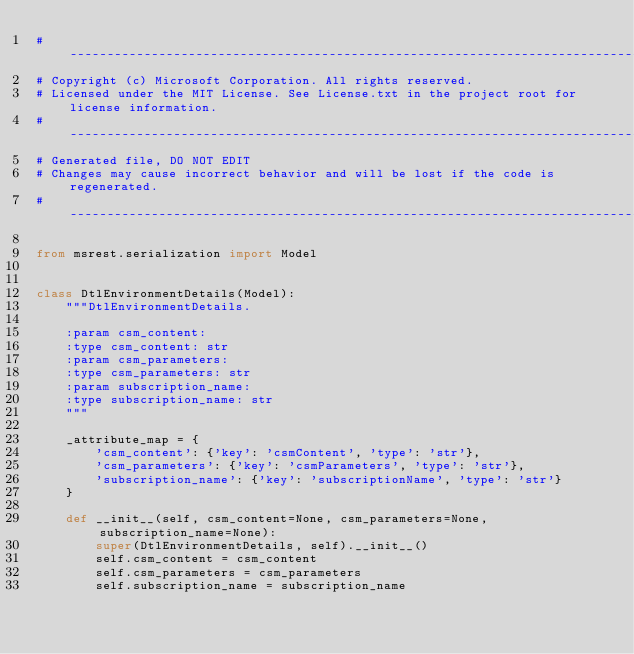<code> <loc_0><loc_0><loc_500><loc_500><_Python_># --------------------------------------------------------------------------------------------
# Copyright (c) Microsoft Corporation. All rights reserved.
# Licensed under the MIT License. See License.txt in the project root for license information.
# --------------------------------------------------------------------------------------------
# Generated file, DO NOT EDIT
# Changes may cause incorrect behavior and will be lost if the code is regenerated.
# --------------------------------------------------------------------------------------------

from msrest.serialization import Model


class DtlEnvironmentDetails(Model):
    """DtlEnvironmentDetails.

    :param csm_content:
    :type csm_content: str
    :param csm_parameters:
    :type csm_parameters: str
    :param subscription_name:
    :type subscription_name: str
    """

    _attribute_map = {
        'csm_content': {'key': 'csmContent', 'type': 'str'},
        'csm_parameters': {'key': 'csmParameters', 'type': 'str'},
        'subscription_name': {'key': 'subscriptionName', 'type': 'str'}
    }

    def __init__(self, csm_content=None, csm_parameters=None, subscription_name=None):
        super(DtlEnvironmentDetails, self).__init__()
        self.csm_content = csm_content
        self.csm_parameters = csm_parameters
        self.subscription_name = subscription_name
</code> 